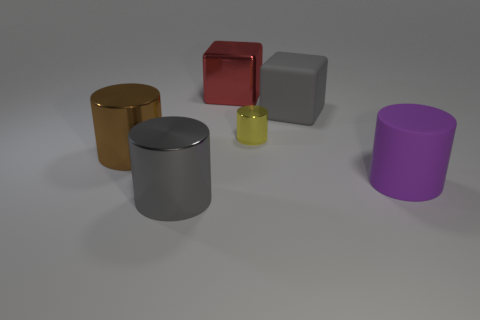Can you describe the texture and color of the object directly to the left of the purple cylinder? Certainly! The object directly to the left of the purple cylinder has a matte texture and a deep gold hue. 